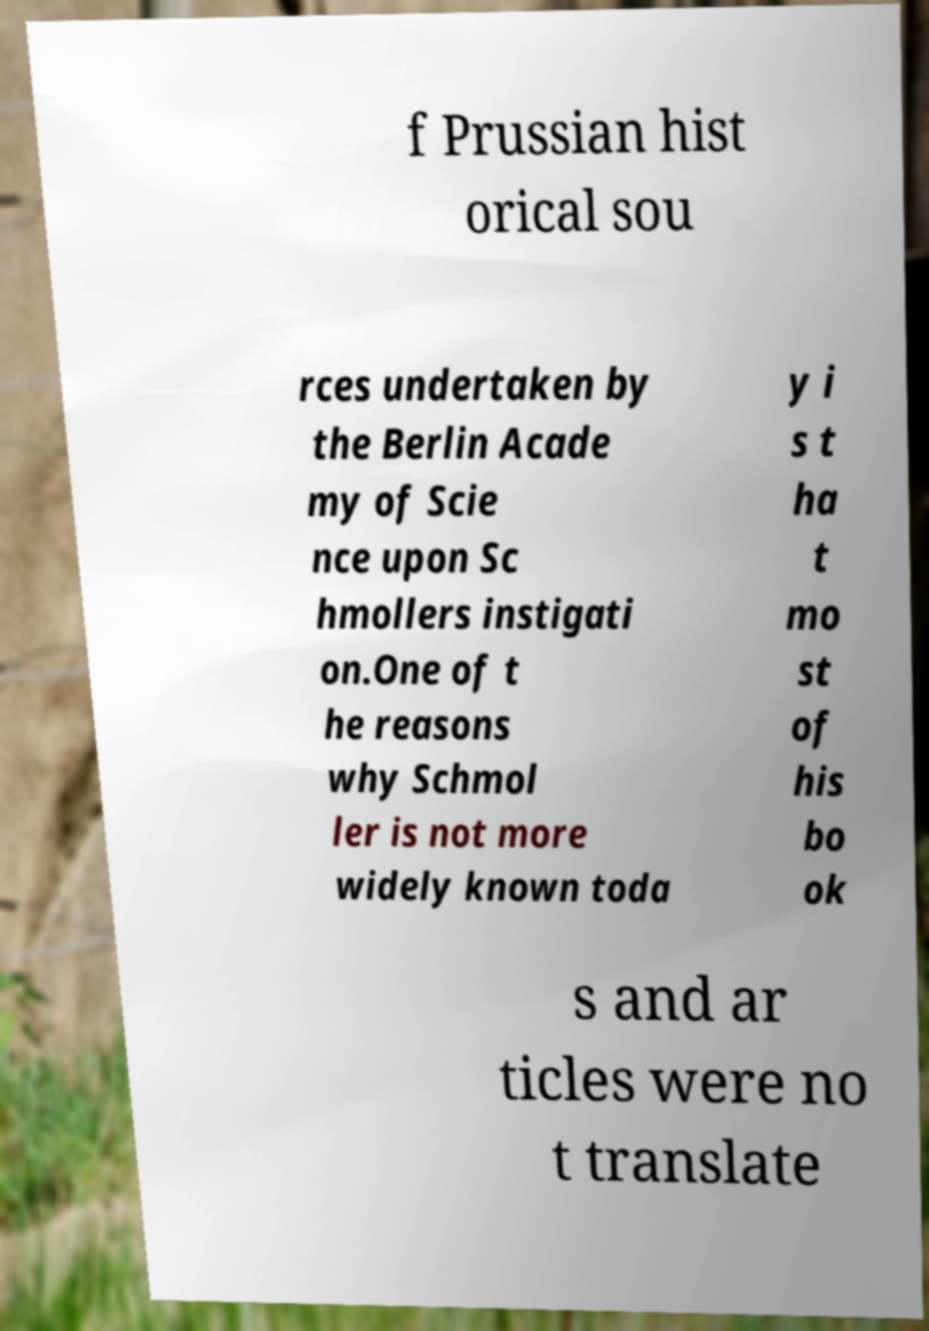I need the written content from this picture converted into text. Can you do that? f Prussian hist orical sou rces undertaken by the Berlin Acade my of Scie nce upon Sc hmollers instigati on.One of t he reasons why Schmol ler is not more widely known toda y i s t ha t mo st of his bo ok s and ar ticles were no t translate 